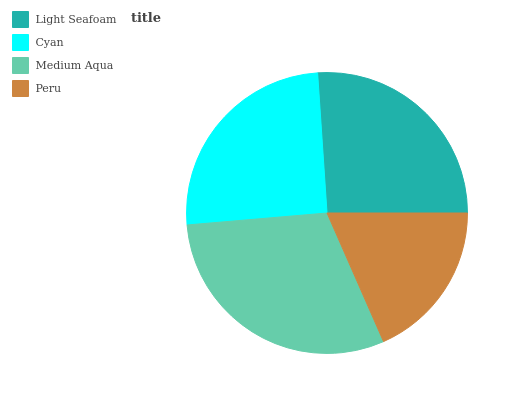Is Peru the minimum?
Answer yes or no. Yes. Is Medium Aqua the maximum?
Answer yes or no. Yes. Is Cyan the minimum?
Answer yes or no. No. Is Cyan the maximum?
Answer yes or no. No. Is Light Seafoam greater than Cyan?
Answer yes or no. Yes. Is Cyan less than Light Seafoam?
Answer yes or no. Yes. Is Cyan greater than Light Seafoam?
Answer yes or no. No. Is Light Seafoam less than Cyan?
Answer yes or no. No. Is Light Seafoam the high median?
Answer yes or no. Yes. Is Cyan the low median?
Answer yes or no. Yes. Is Peru the high median?
Answer yes or no. No. Is Peru the low median?
Answer yes or no. No. 